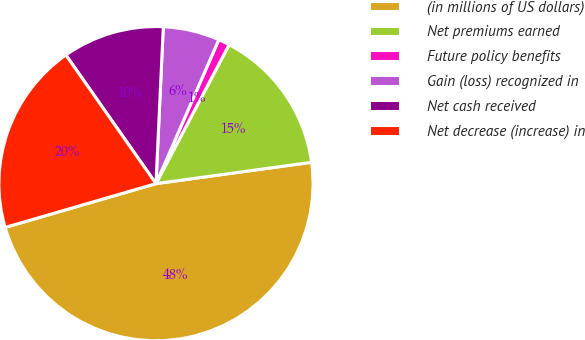Convert chart. <chart><loc_0><loc_0><loc_500><loc_500><pie_chart><fcel>(in millions of US dollars)<fcel>Net premiums earned<fcel>Future policy benefits<fcel>Gain (loss) recognized in<fcel>Net cash received<fcel>Net decrease (increase) in<nl><fcel>47.67%<fcel>15.12%<fcel>1.16%<fcel>5.81%<fcel>10.47%<fcel>19.77%<nl></chart> 